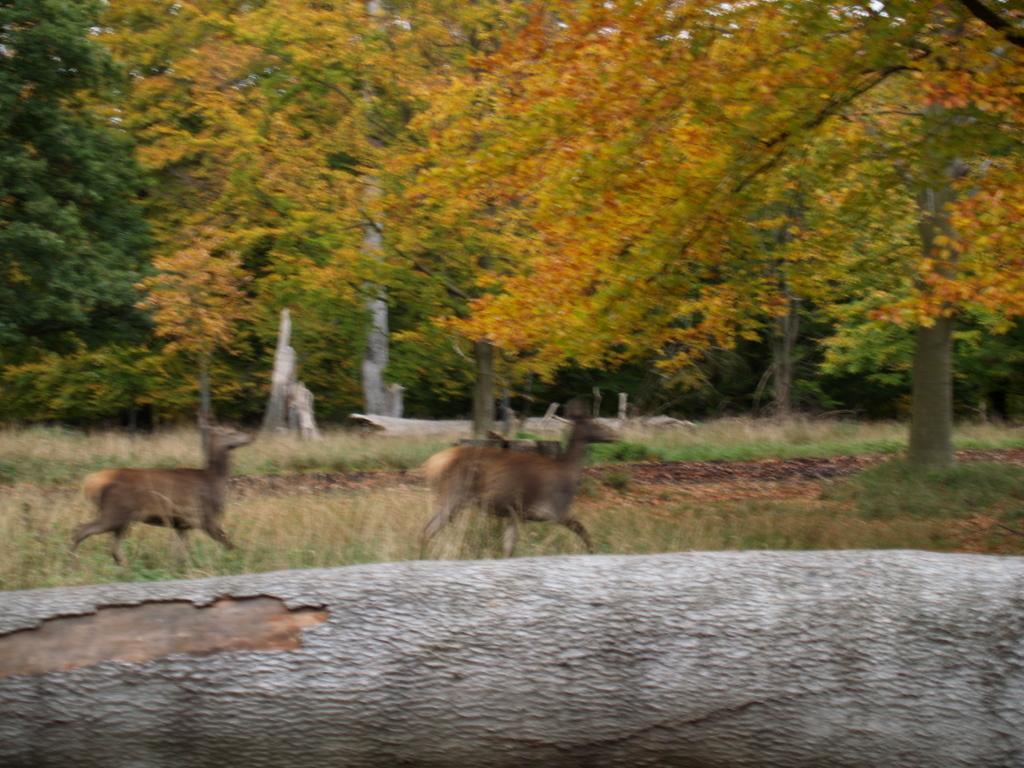In one or two sentences, can you explain what this image depicts? Here we can see animals. Background there are a number of trees. 